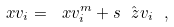<formula> <loc_0><loc_0><loc_500><loc_500>\ x v _ { i } = \ x v ^ { m } _ { i } + s \hat { \ z v } _ { i } \ ,</formula> 